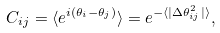<formula> <loc_0><loc_0><loc_500><loc_500>C _ { i j } = \langle e ^ { i ( \theta _ { i } - \theta _ { j } ) } \rangle = e ^ { - \langle | \Delta \theta _ { i j } ^ { 2 } | \rangle } ,</formula> 